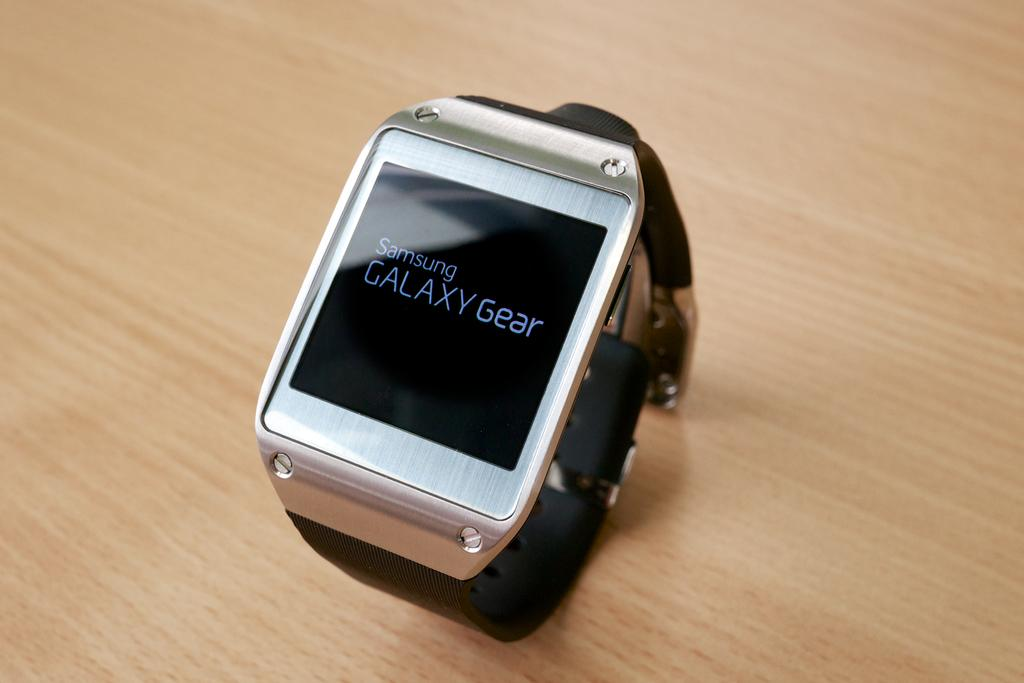Provide a one-sentence caption for the provided image. A Samsung galaxy gear smartwatch on a wooden table. 